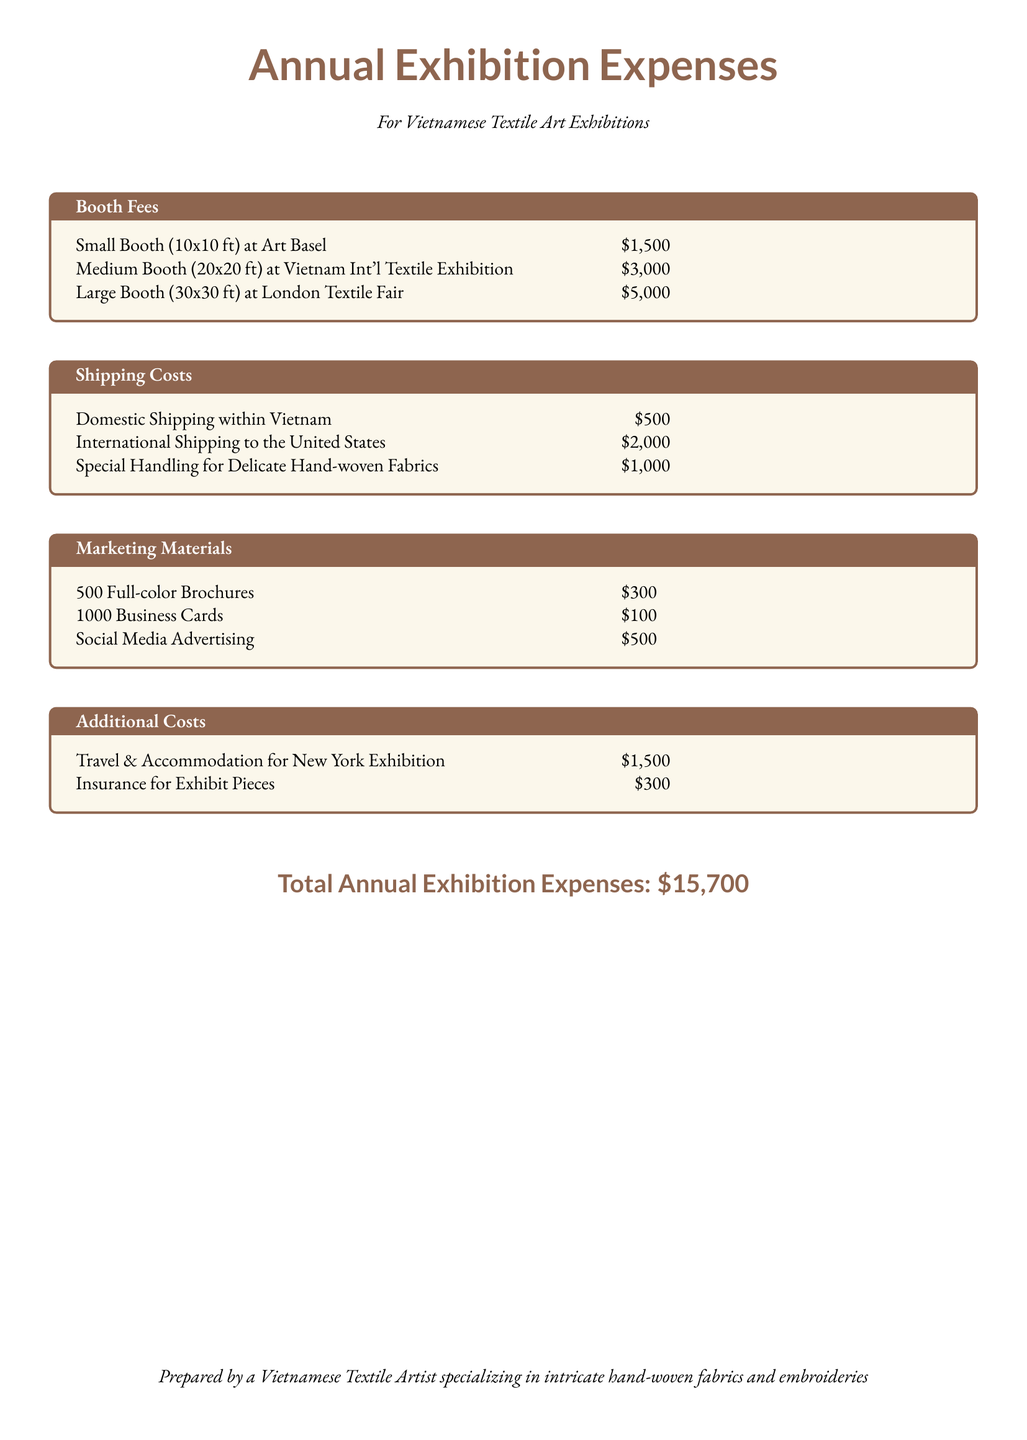What is the total annual exhibition expense? The total annual exhibition expense is presented in the conclusion section of the document.
Answer: $15,700 What is the cost of a large booth at the London Textile Fair? The cost for the large booth is listed under the Booth Fees section of the document.
Answer: $5,000 How much does domestic shipping within Vietnam cost? The cost for domestic shipping is detailed in the Shipping Costs section of the document.
Answer: $500 What is the cost of social media advertising? The expense for social media advertising is found in the Marketing Materials section.
Answer: $500 What is the shipping cost for international shipping to the United States? The shipping cost for international shipping can be found under the Shipping Costs section of the document.
Answer: $2,000 What is the combined cost of travel and accommodation for the New York exhibition and insurance for exhibit pieces? The reasoning requires summing the costs listed under Additional Costs section of the document.
Answer: $1,800 How many business cards are included in the marketing materials? The number of business cards is specified in the Marketing Materials section of the document.
Answer: 1000 What type of exhibition is related to the total annual exhibition expenses? The type of exhibition refers to the specific category mentioned in the title of the document.
Answer: Vietnamese Textile Art Exhibitions What are the additional costs besides booth fees, shipping, and marketing materials? The section titled Additional Costs lists costs that do not fall under the other three categories.
Answer: Travel & Accommodation, Insurance 